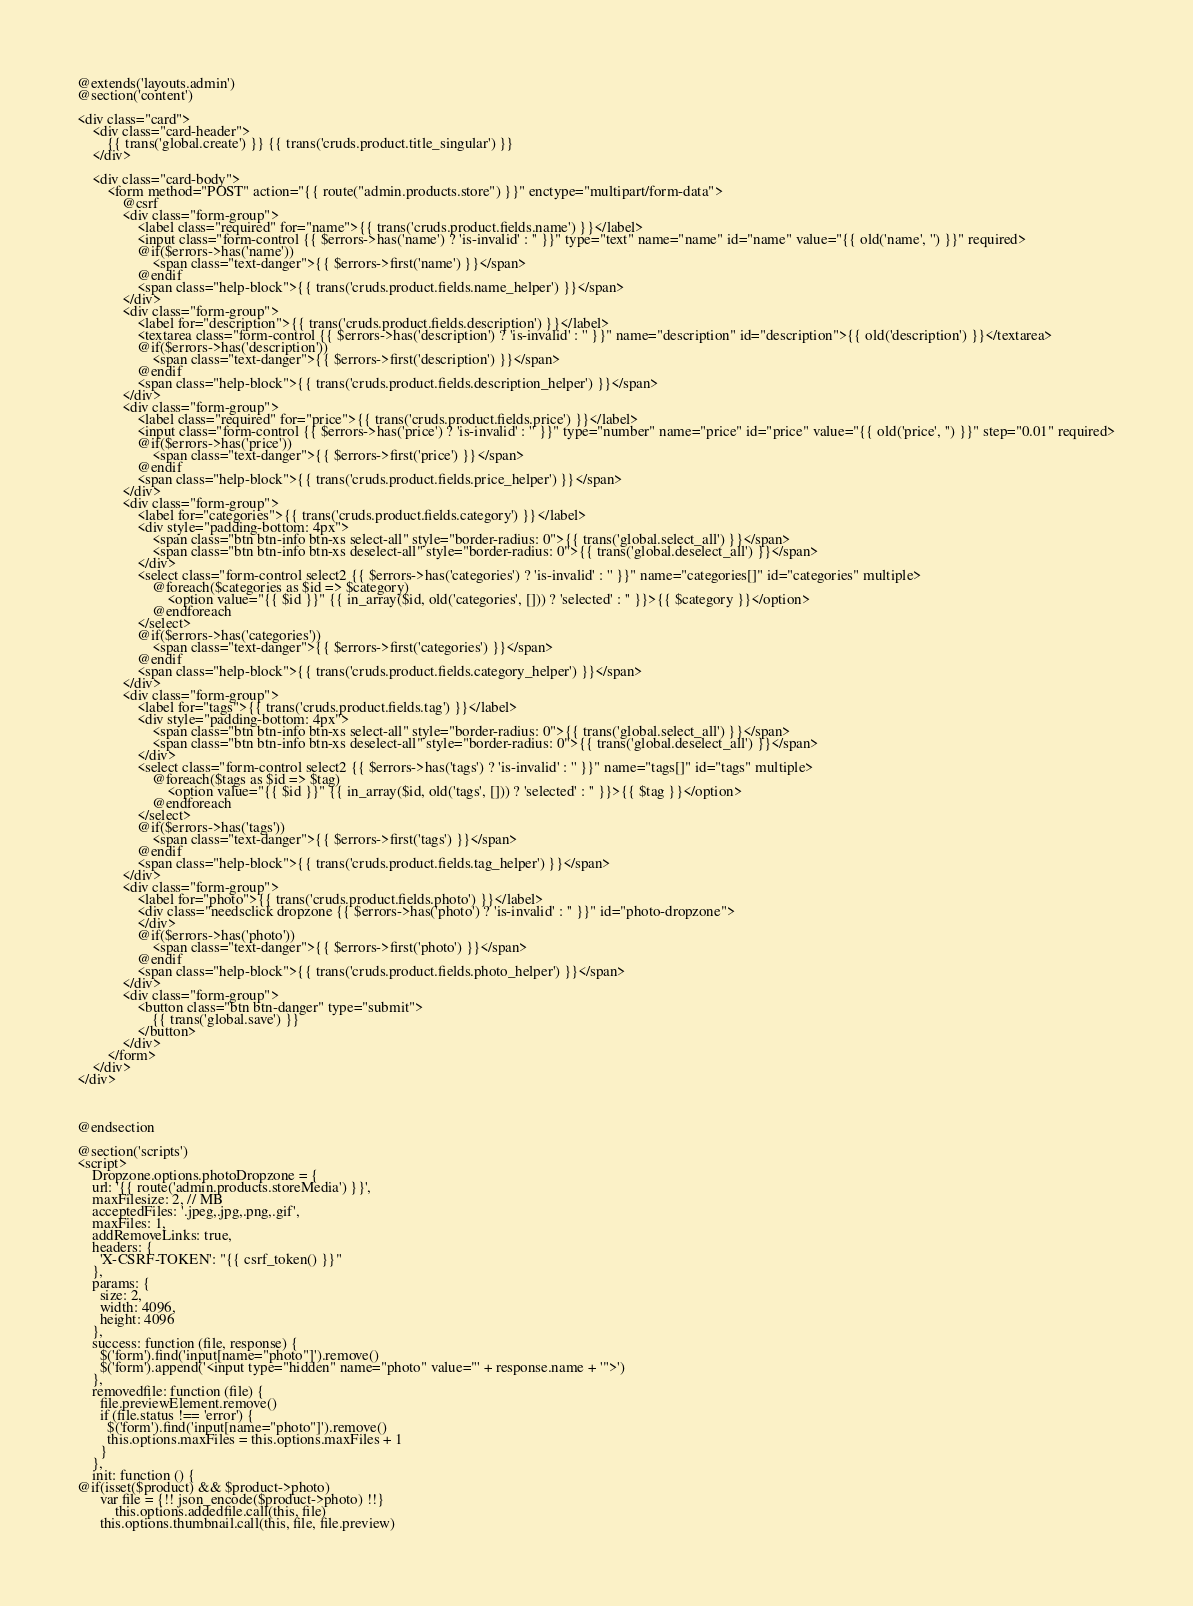<code> <loc_0><loc_0><loc_500><loc_500><_PHP_>@extends('layouts.admin')
@section('content')

<div class="card">
    <div class="card-header">
        {{ trans('global.create') }} {{ trans('cruds.product.title_singular') }}
    </div>

    <div class="card-body">
        <form method="POST" action="{{ route("admin.products.store") }}" enctype="multipart/form-data">
            @csrf
            <div class="form-group">
                <label class="required" for="name">{{ trans('cruds.product.fields.name') }}</label>
                <input class="form-control {{ $errors->has('name') ? 'is-invalid' : '' }}" type="text" name="name" id="name" value="{{ old('name', '') }}" required>
                @if($errors->has('name'))
                    <span class="text-danger">{{ $errors->first('name') }}</span>
                @endif
                <span class="help-block">{{ trans('cruds.product.fields.name_helper') }}</span>
            </div>
            <div class="form-group">
                <label for="description">{{ trans('cruds.product.fields.description') }}</label>
                <textarea class="form-control {{ $errors->has('description') ? 'is-invalid' : '' }}" name="description" id="description">{{ old('description') }}</textarea>
                @if($errors->has('description'))
                    <span class="text-danger">{{ $errors->first('description') }}</span>
                @endif
                <span class="help-block">{{ trans('cruds.product.fields.description_helper') }}</span>
            </div>
            <div class="form-group">
                <label class="required" for="price">{{ trans('cruds.product.fields.price') }}</label>
                <input class="form-control {{ $errors->has('price') ? 'is-invalid' : '' }}" type="number" name="price" id="price" value="{{ old('price', '') }}" step="0.01" required>
                @if($errors->has('price'))
                    <span class="text-danger">{{ $errors->first('price') }}</span>
                @endif
                <span class="help-block">{{ trans('cruds.product.fields.price_helper') }}</span>
            </div>
            <div class="form-group">
                <label for="categories">{{ trans('cruds.product.fields.category') }}</label>
                <div style="padding-bottom: 4px">
                    <span class="btn btn-info btn-xs select-all" style="border-radius: 0">{{ trans('global.select_all') }}</span>
                    <span class="btn btn-info btn-xs deselect-all" style="border-radius: 0">{{ trans('global.deselect_all') }}</span>
                </div>
                <select class="form-control select2 {{ $errors->has('categories') ? 'is-invalid' : '' }}" name="categories[]" id="categories" multiple>
                    @foreach($categories as $id => $category)
                        <option value="{{ $id }}" {{ in_array($id, old('categories', [])) ? 'selected' : '' }}>{{ $category }}</option>
                    @endforeach
                </select>
                @if($errors->has('categories'))
                    <span class="text-danger">{{ $errors->first('categories') }}</span>
                @endif
                <span class="help-block">{{ trans('cruds.product.fields.category_helper') }}</span>
            </div>
            <div class="form-group">
                <label for="tags">{{ trans('cruds.product.fields.tag') }}</label>
                <div style="padding-bottom: 4px">
                    <span class="btn btn-info btn-xs select-all" style="border-radius: 0">{{ trans('global.select_all') }}</span>
                    <span class="btn btn-info btn-xs deselect-all" style="border-radius: 0">{{ trans('global.deselect_all') }}</span>
                </div>
                <select class="form-control select2 {{ $errors->has('tags') ? 'is-invalid' : '' }}" name="tags[]" id="tags" multiple>
                    @foreach($tags as $id => $tag)
                        <option value="{{ $id }}" {{ in_array($id, old('tags', [])) ? 'selected' : '' }}>{{ $tag }}</option>
                    @endforeach
                </select>
                @if($errors->has('tags'))
                    <span class="text-danger">{{ $errors->first('tags') }}</span>
                @endif
                <span class="help-block">{{ trans('cruds.product.fields.tag_helper') }}</span>
            </div>
            <div class="form-group">
                <label for="photo">{{ trans('cruds.product.fields.photo') }}</label>
                <div class="needsclick dropzone {{ $errors->has('photo') ? 'is-invalid' : '' }}" id="photo-dropzone">
                </div>
                @if($errors->has('photo'))
                    <span class="text-danger">{{ $errors->first('photo') }}</span>
                @endif
                <span class="help-block">{{ trans('cruds.product.fields.photo_helper') }}</span>
            </div>
            <div class="form-group">
                <button class="btn btn-danger" type="submit">
                    {{ trans('global.save') }}
                </button>
            </div>
        </form>
    </div>
</div>



@endsection

@section('scripts')
<script>
    Dropzone.options.photoDropzone = {
    url: '{{ route('admin.products.storeMedia') }}',
    maxFilesize: 2, // MB
    acceptedFiles: '.jpeg,.jpg,.png,.gif',
    maxFiles: 1,
    addRemoveLinks: true,
    headers: {
      'X-CSRF-TOKEN': "{{ csrf_token() }}"
    },
    params: {
      size: 2,
      width: 4096,
      height: 4096
    },
    success: function (file, response) {
      $('form').find('input[name="photo"]').remove()
      $('form').append('<input type="hidden" name="photo" value="' + response.name + '">')
    },
    removedfile: function (file) {
      file.previewElement.remove()
      if (file.status !== 'error') {
        $('form').find('input[name="photo"]').remove()
        this.options.maxFiles = this.options.maxFiles + 1
      }
    },
    init: function () {
@if(isset($product) && $product->photo)
      var file = {!! json_encode($product->photo) !!}
          this.options.addedfile.call(this, file)
      this.options.thumbnail.call(this, file, file.preview)</code> 